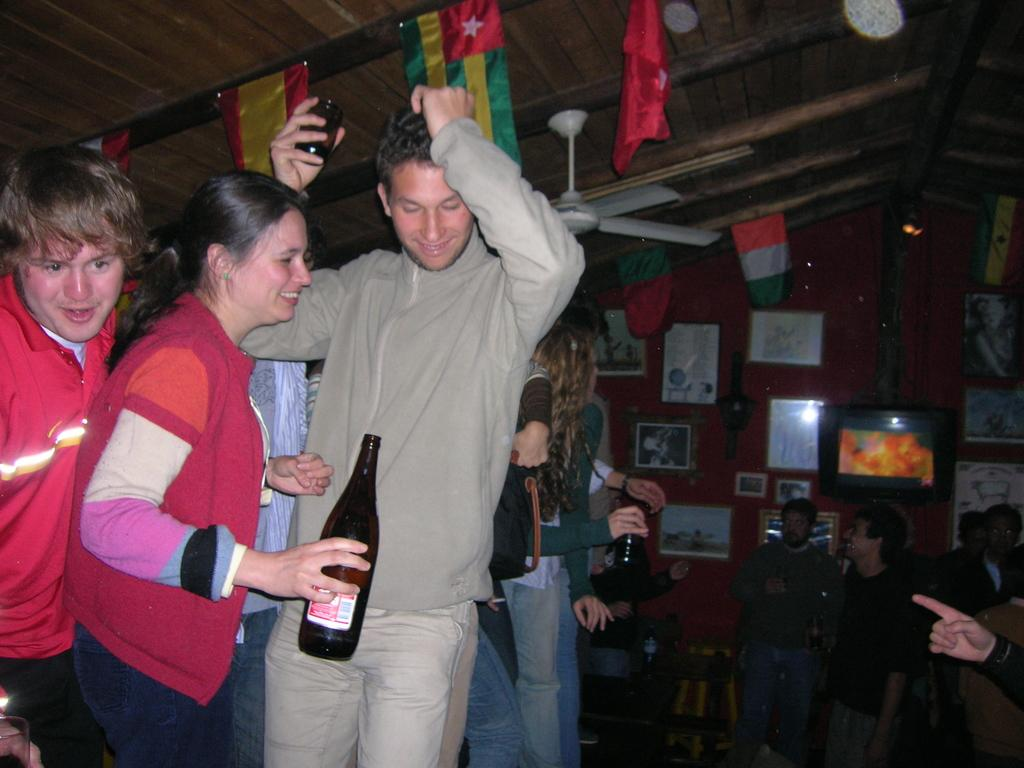How many people are in the image? There is a group of people in the image. What are some of the people holding in their hands? Some people are holding bottles in their hands. What can be seen in the background of the image? There are flags, a fan, and frames on the wall in the background of the image. What type of sand can be seen on the floor in the image? There is no sand present in the image; it features a group of people, flags, a fan, and frames on the wall. 